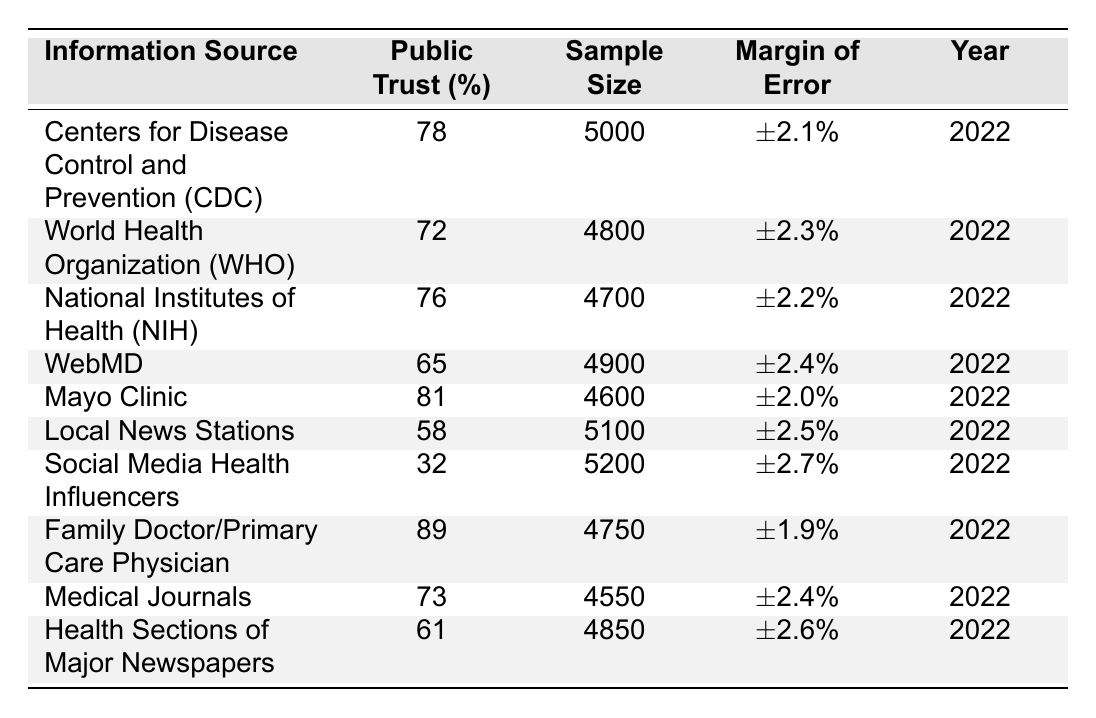What is the public trust percentage in the Mayo Clinic? The table shows that the public trust percentage in the Mayo Clinic is listed as 81%.
Answer: 81% Which information source has the lowest public trust percentage? By comparing the percentages in the table, Social Media Health Influencers has the lowest trust percentage at 32%.
Answer: 32% What is the sample size for the Centers for Disease Control and Prevention (CDC)? The sample size for the CDC is provided in the table as 5000.
Answer: 5000 Is the margin of error for the Family Doctor/Primary Care Physician higher or lower than 2%? The margin of error for Family Doctor/Primary Care Physician is ±1.9%, which is lower than 2%.
Answer: Lower What is the average public trust percentage of all mentioned health information sources? To calculate the average, first sum the trust percentages: (78 + 72 + 76 + 65 + 81 + 58 + 32 + 89 + 73 + 61) =  683. Then divide by the number of sources (10): 683/10 = 68.3%.
Answer: 68.3% How many information sources have a public trust percentage above 75%? By reviewing the table, the sources with percentages above 75% are CDC (78%), NIH (76%), Mayo Clinic (81%), and Family Doctor (89%). There are 4 sources in total.
Answer: 4 What percentage of public trust does Health Sections of Major Newspapers have compared to WebMD? Health Sections of Major Newspapers have a trust percentage of 61%, while WebMD's is 65%. Therefore, WebMD has a higher percentage than Health Sections of Major Newspapers by 4%.
Answer: 4% Which has a higher public trust percentage: World Health Organization (WHO) or Medical Journals? The table indicates that WHO has a trust percentage of 72% and Medical Journals have 73%. Therefore, Medical Journals have a higher percentage by 1%.
Answer: Medical Journals What is the overall public trust in local news stations compared to social media health influencers? Local News Stations have a trust percentage of 58%, while Social Media Health Influencers have 32%. Comparing these, Local News Stations have 26% higher trust than Social Media Health Influencers.
Answer: 26% 